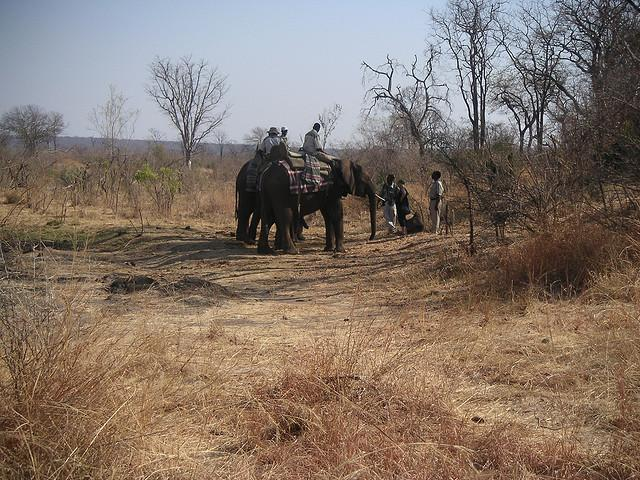Why is there a saddle on the elephant? riding 